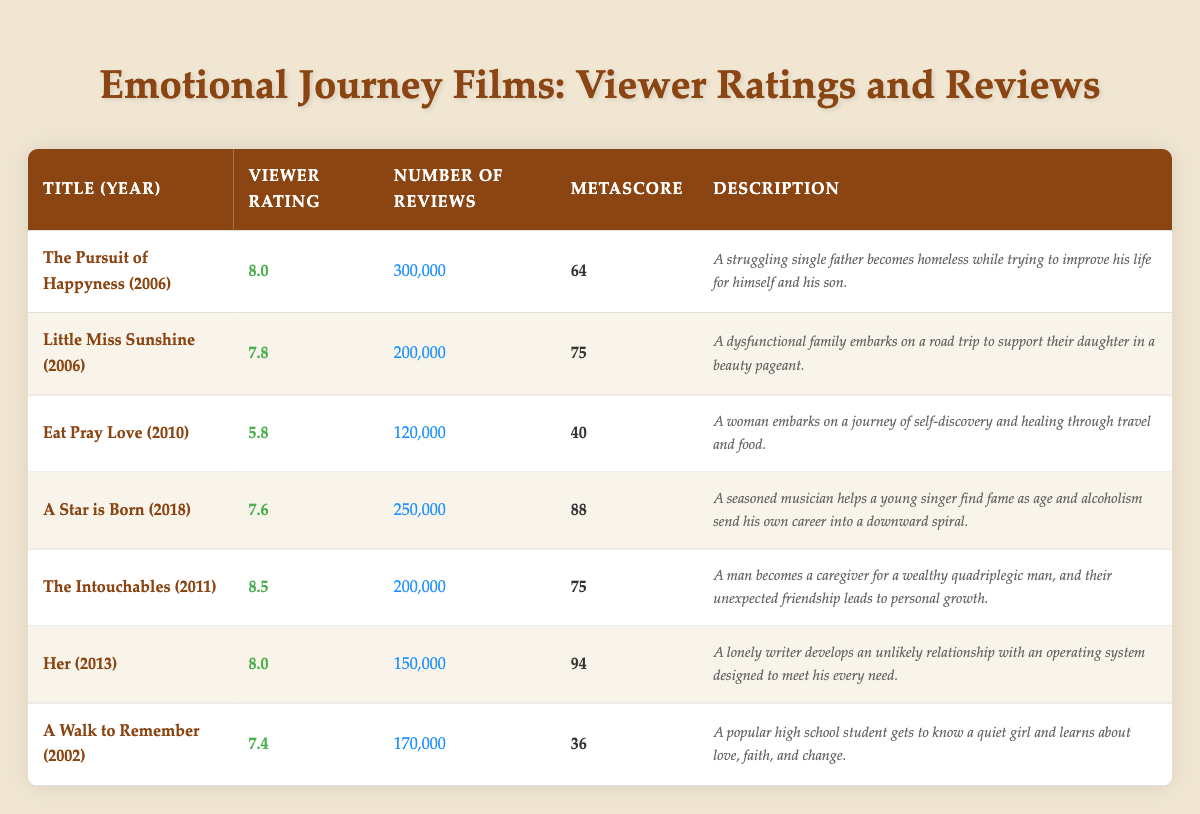What is the viewer rating of "The Intouchables"? The viewer rating is a single direct value from the table in the corresponding column. For "The Intouchables," the viewer rating is listed as 8.5.
Answer: 8.5 Which film has the highest number of reviews? To determine which film has the highest number of reviews, we can compare the values in the "Number of Reviews" column. "The Pursuit of Happyness" has 300,000 reviews, which is greater than the reviews for all other films in the table.
Answer: The Pursuit of Happyness What is the average viewer rating of all the films listed? We sum the viewer ratings of all films: (8.0 + 7.8 + 5.8 + 7.6 + 8.5 + 8.0 + 7.4) = 54.1. There are 7 films, so we divide the total by 7 to get the average: 54.1 / 7 ≈ 7.73.
Answer: 7.73 Is "Eat Pray Love" rated higher than "A Walk to Remember"? We compare the viewer rating of both films: "Eat Pray Love" has a rating of 5.8 while "A Walk to Remember" has a rating of 7.4. Since 5.8 is less than 7.4, we conclude that "Eat Pray Love" is not rated higher.
Answer: No What is the metascore of the film with the lowest viewer rating? First, we identify the film with the lowest viewer rating. "Eat Pray Love" has a rating of 5.8, which is the lowest. Then we look at its metascore, which is 40.
Answer: 40 How many films have a viewer rating of 8.0 or higher? We check the "Viewer Rating" column and find that the ratings of "The Intouchables" (8.5), "Her" (8.0), and "The Pursuit of Happyness" (8.0) meet the criteria. Therefore, there are 3 films with a rating of 8.0 or higher.
Answer: 3 Which film released in 2011 has the highest viewer rating? Looking at the table, the films released in 2011 are "The Intouchables" (8.5) and there are no other 2011 films listed. Since this is the only one, it automatically has the highest rating for that year.
Answer: The Intouchables Was "A Star is Born" released before or after 2011? We can find the release year for "A Star is Born" directly from the table, which states it was released in 2018. Therefore, it was released after 2011.
Answer: After What is the difference in viewer ratings between "Her" and "Little Miss Sunshine"? We subtract the viewer rating of "Little Miss Sunshine" (7.8) from that of "Her" (8.0) to find the difference: 8.0 - 7.8 = 0.2.
Answer: 0.2 